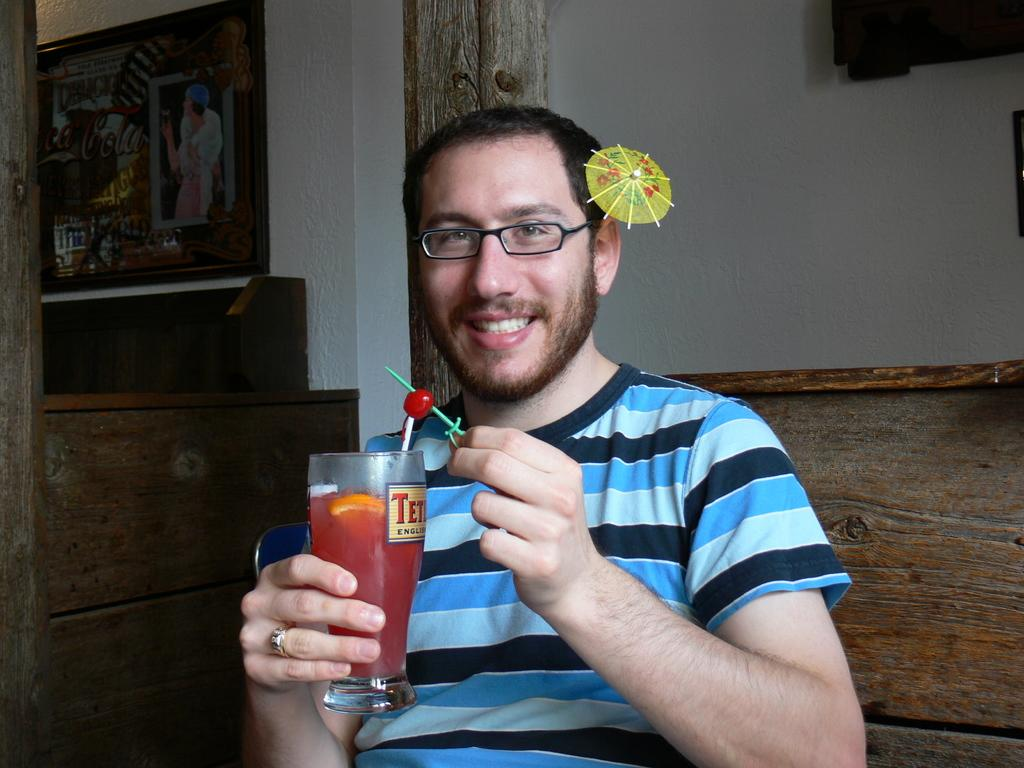Who is present in the image? There is a man in the image. What is the man holding in his hand? The man is holding a juice glass in his hand. What is the man's posture in the image? The man is sitting. What can be seen in the background of the image? There is a wall and a wall painting in the background of the image. Where was the image taken? The image was taken in a room. What type of plantation does the man own, as seen in the image? There is no mention of a plantation or any ownership in the image. The man is simply holding a juice glass and sitting in a room with a wall painting in the background. 